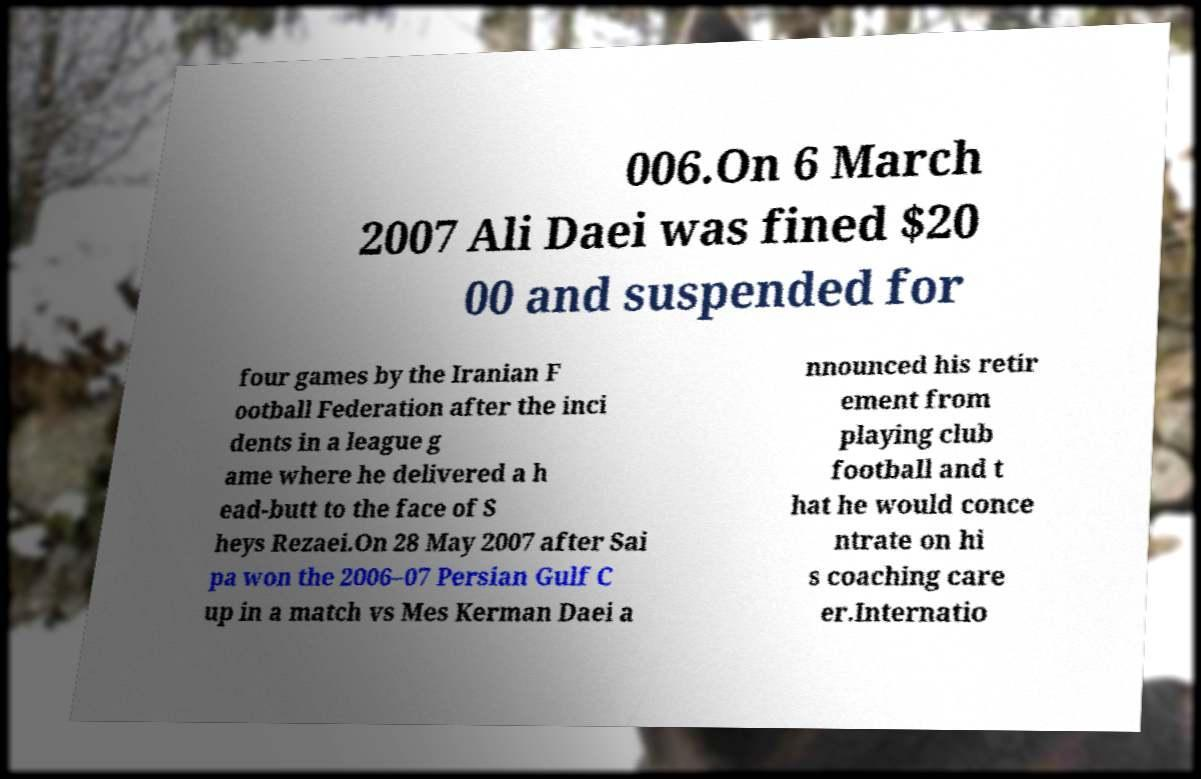Could you assist in decoding the text presented in this image and type it out clearly? 006.On 6 March 2007 Ali Daei was fined $20 00 and suspended for four games by the Iranian F ootball Federation after the inci dents in a league g ame where he delivered a h ead-butt to the face of S heys Rezaei.On 28 May 2007 after Sai pa won the 2006–07 Persian Gulf C up in a match vs Mes Kerman Daei a nnounced his retir ement from playing club football and t hat he would conce ntrate on hi s coaching care er.Internatio 